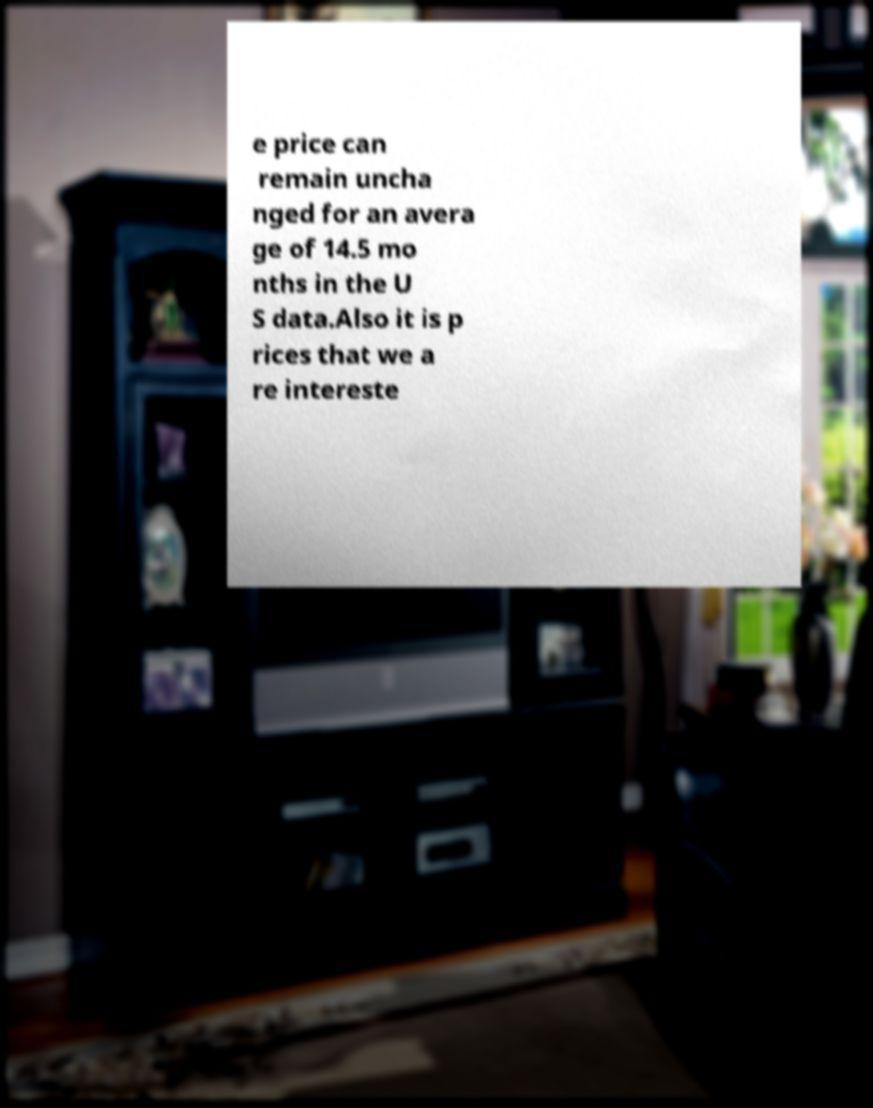Please identify and transcribe the text found in this image. e price can remain uncha nged for an avera ge of 14.5 mo nths in the U S data.Also it is p rices that we a re intereste 